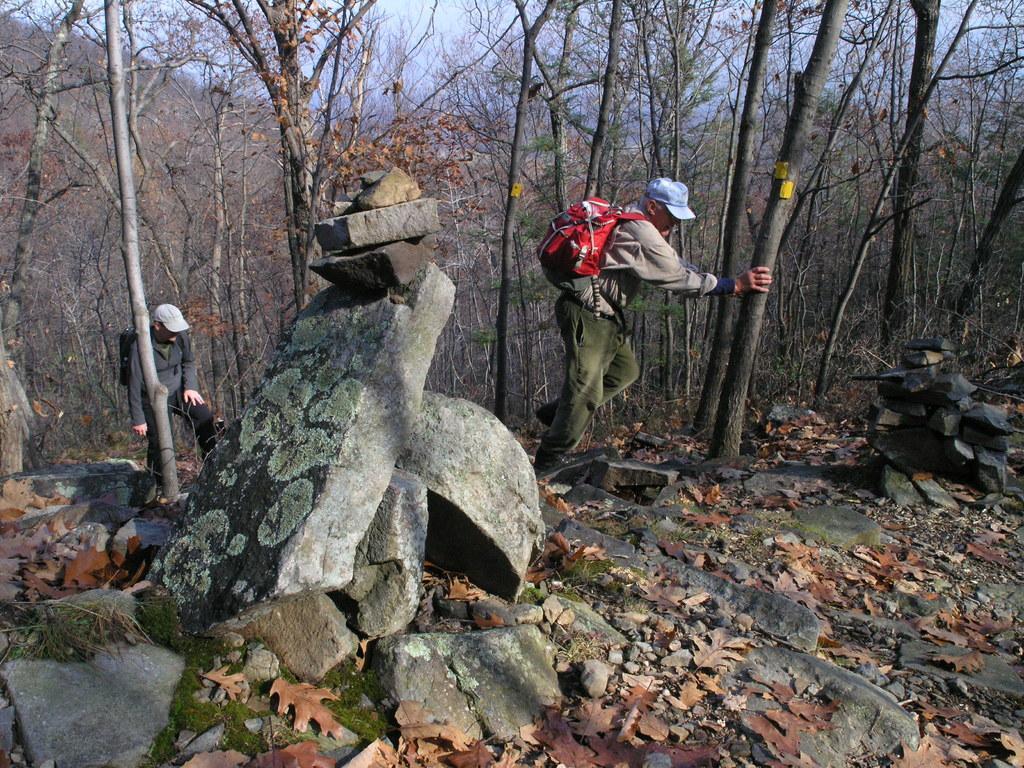Could you give a brief overview of what you see in this image? In the center of the image a man is standing and wearing bag, cap and pushing a tree. On the left side of the image a man is standing and wearing bag and cap. At the bottom of the image we can see some rocks and dry leaves. In the background of the image we can see the trees. At the top of the image we can see the sky. 